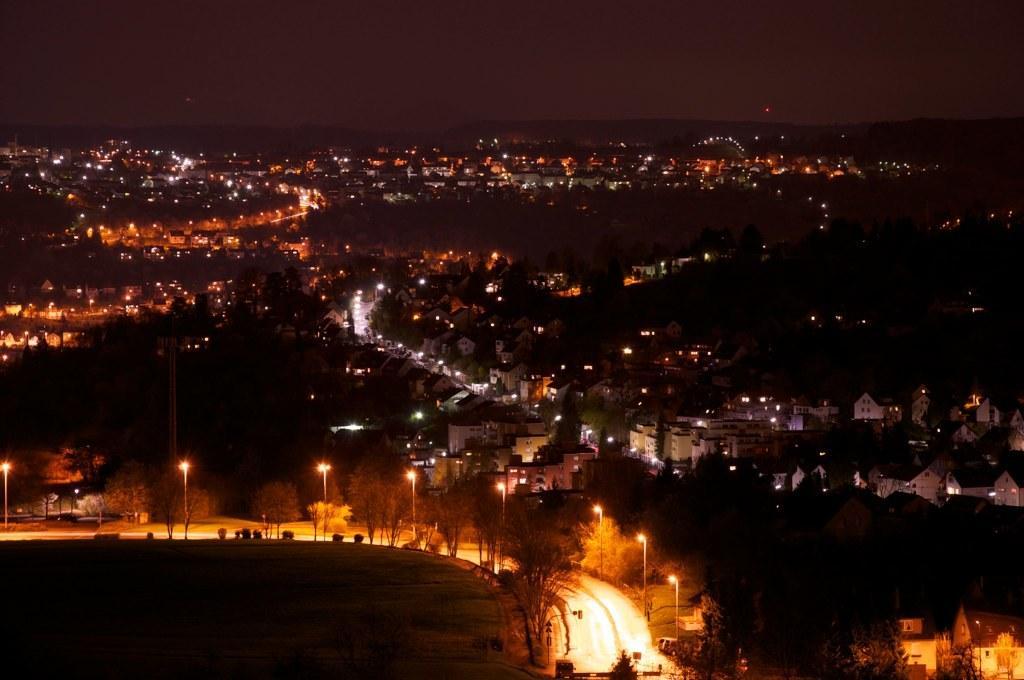Could you give a brief overview of what you see in this image? In this image there is a road. There are few street lights beside the road. There are few buildings and trees on the land. Top of the image there is sky. 